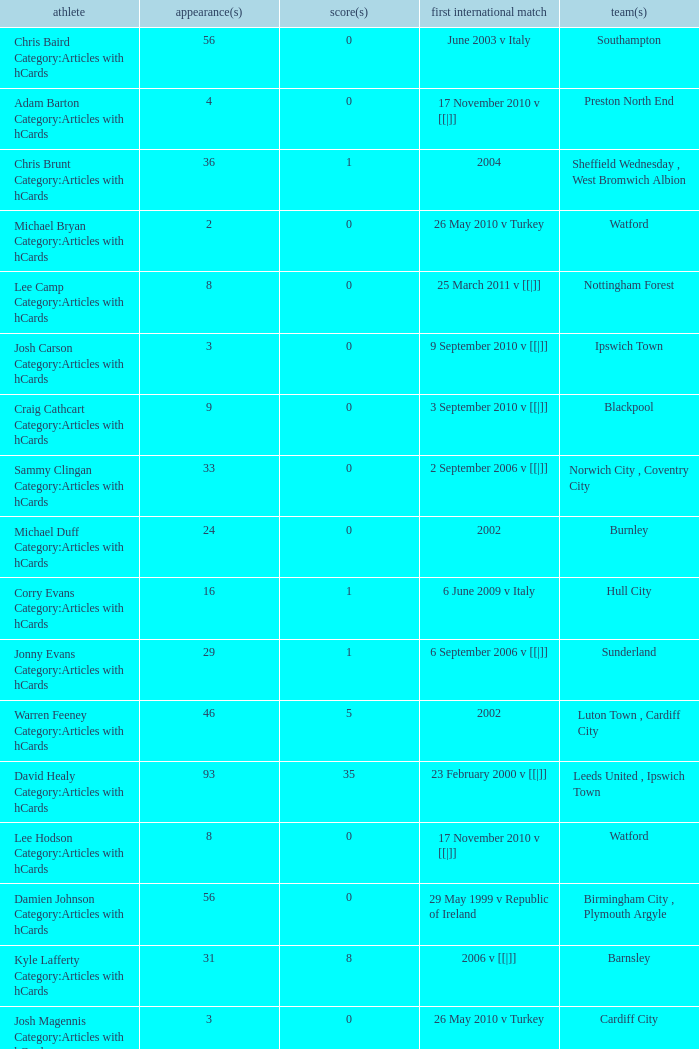How many caps figures are there for Norwich City, Coventry City? 1.0. 